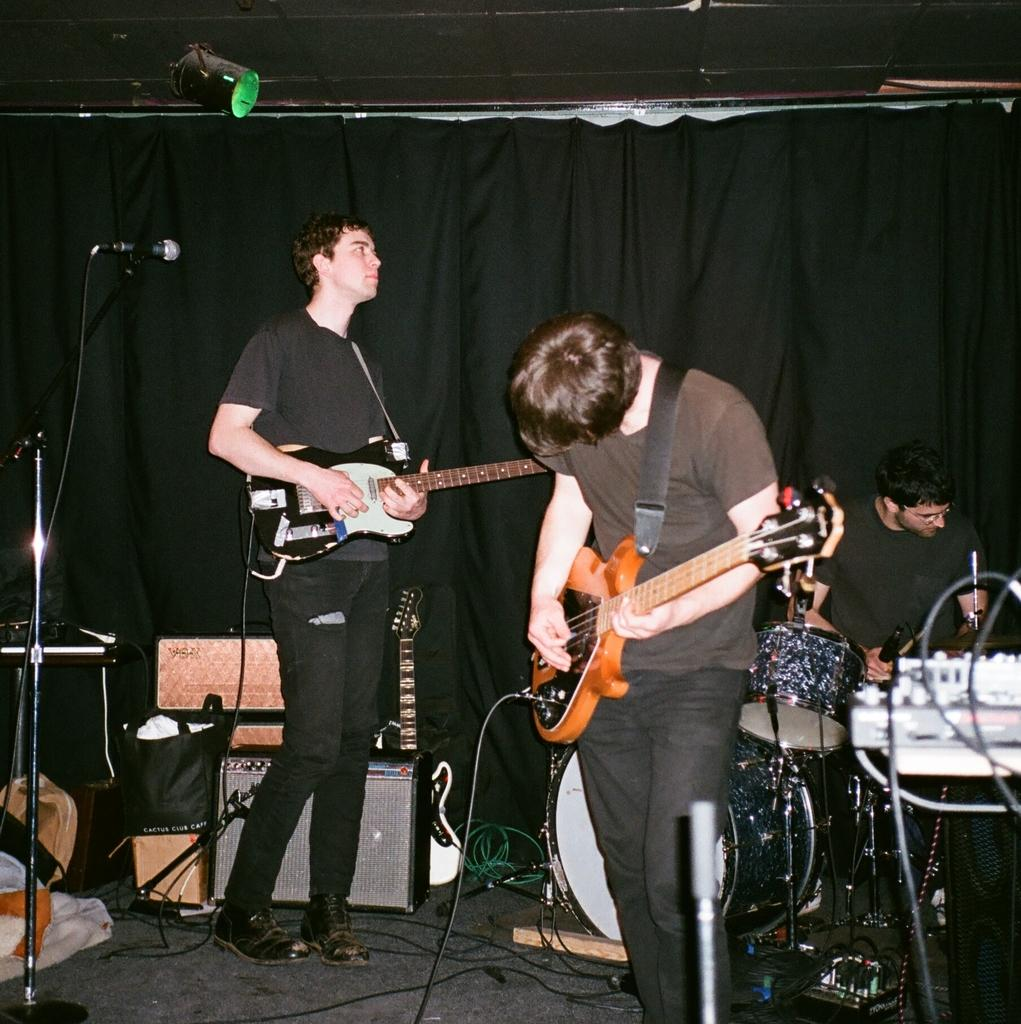How many people are in the image? There are two men in the image. What are the men doing in the image? The men are standing and playing guitar. What object is present for amplifying sound in the image? There is a microphone in the image. What other items related to music can be seen in the image? There are musical instruments in the image. What type of nose can be seen on the guitar in the image? There is no nose present on the guitar in the image. What is the aftermath of the musical performance in the image? The image does not depict an aftermath of a musical performance; it shows two men playing guitar. 